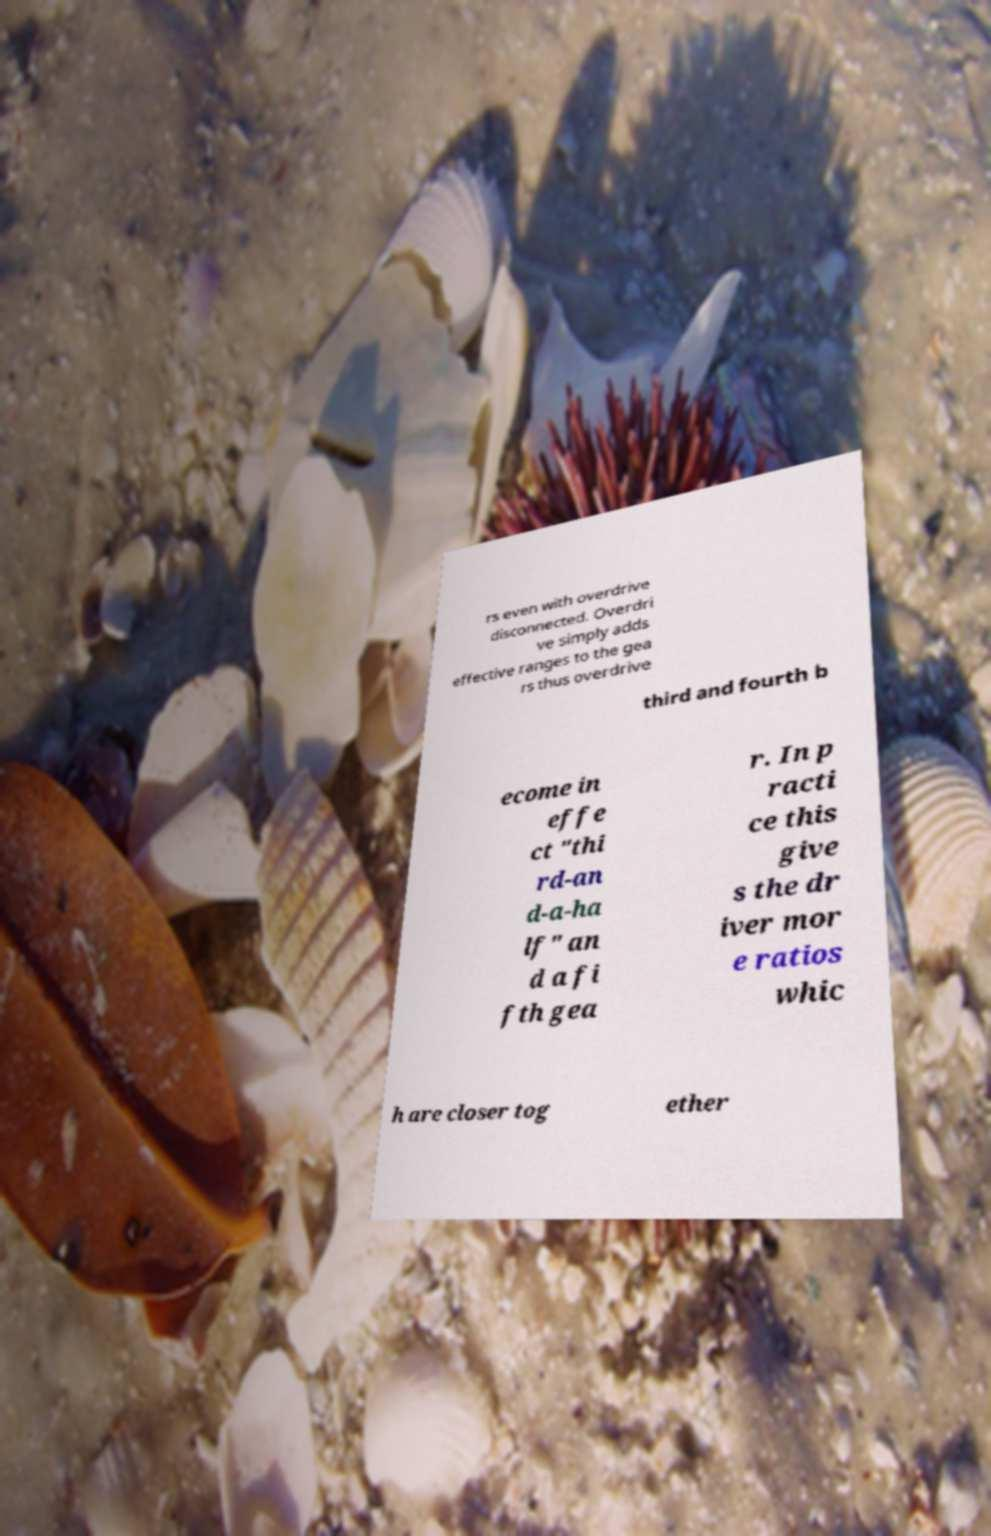What messages or text are displayed in this image? I need them in a readable, typed format. rs even with overdrive disconnected. Overdri ve simply adds effective ranges to the gea rs thus overdrive third and fourth b ecome in effe ct "thi rd-an d-a-ha lf" an d a fi fth gea r. In p racti ce this give s the dr iver mor e ratios whic h are closer tog ether 